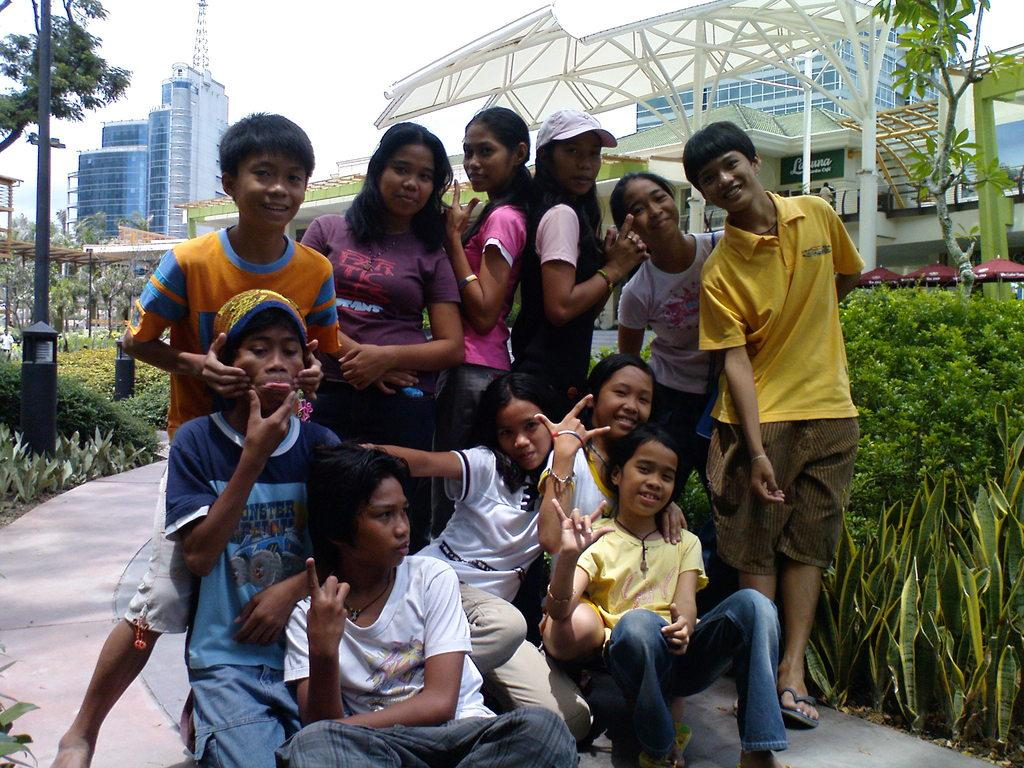What are the people in the image doing? The people in the image are posing for a photo. What can be seen in the background of the image? There are trees, buildings, and shrubs in the background of the image. What type of whistle can be heard in the background of the image? There is no whistle present in the image, as it is a still photograph. 